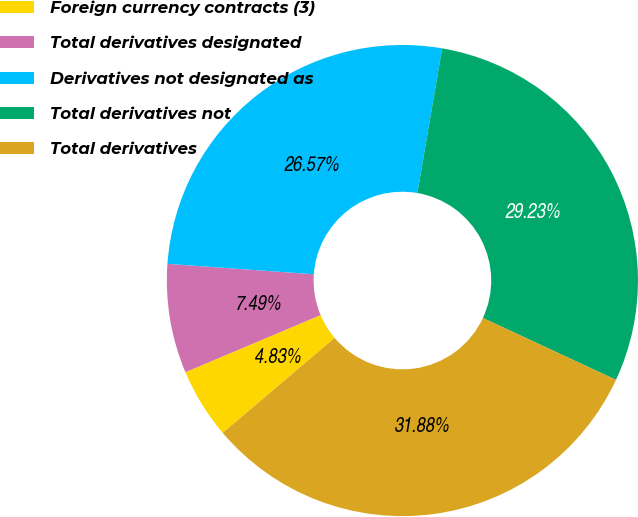Convert chart to OTSL. <chart><loc_0><loc_0><loc_500><loc_500><pie_chart><fcel>Foreign currency contracts (3)<fcel>Total derivatives designated<fcel>Derivatives not designated as<fcel>Total derivatives not<fcel>Total derivatives<nl><fcel>4.83%<fcel>7.49%<fcel>26.57%<fcel>29.23%<fcel>31.88%<nl></chart> 